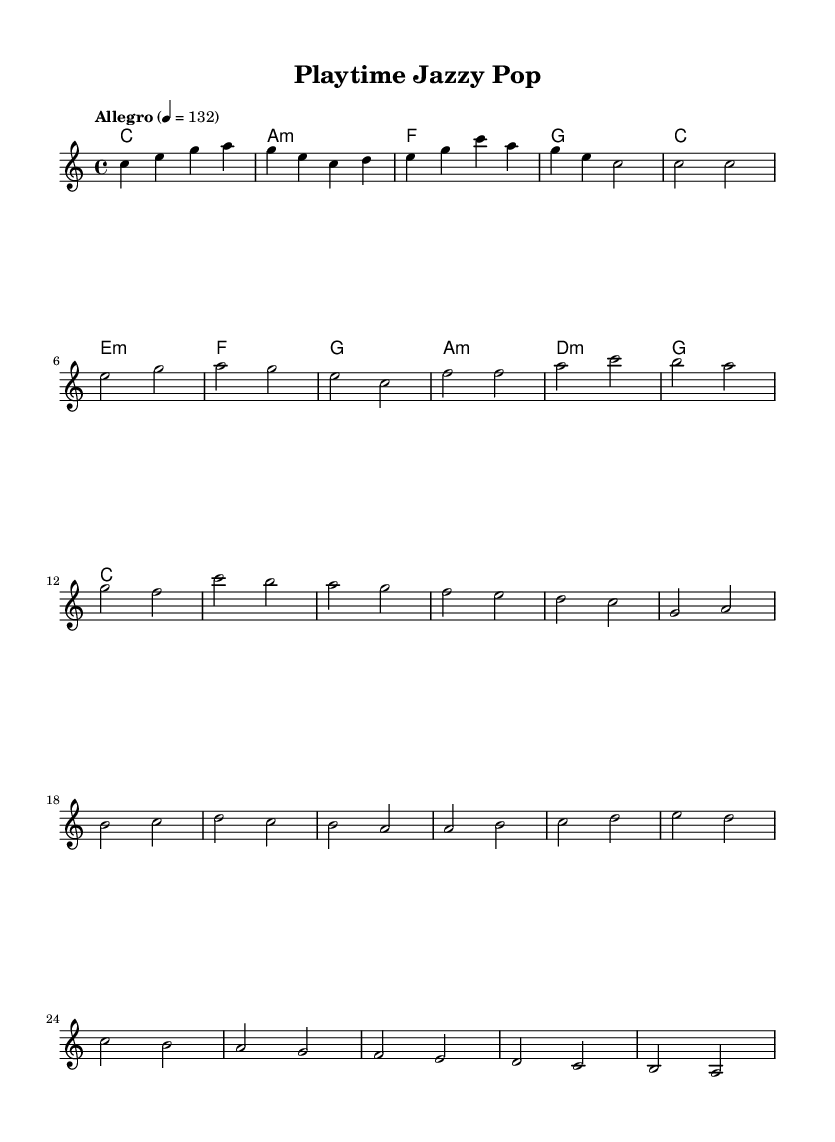What is the key signature of this music? The key signature is indicated at the beginning of the staff, showing no sharps or flats, which signifies that the piece is in C major.
Answer: C major What is the time signature of this music? The time signature is indicated at the beginning of the music as 4/4, meaning there are four beats in each measure.
Answer: 4/4 What is the tempo marking for this piece? The tempo marking at the beginning states "Allegro" with a metronome indication of 132 beats per minute, suggesting a fast, lively pace.
Answer: Allegro, 132 How many measures are in the verse section? The verse section is comprised of four measures, as noted by measuring the bar lines present in that section of the music.
Answer: 4 What are the first four notes of the melody? The first four notes of the melody are indicated in the intro section and are C, E, G, A, represented in a rising order in the notes.
Answer: C, E, G, A Which chords are used in the chorus? The chords in the chorus consist of F, E minor, D minor, and C, as indicated in the chord progression shown above the melody.
Answer: F, E minor, D minor, C What is the characteristic sound of the fusion style represented in this sheet? The fusion style combines upbeat jazz rhythms with pop melodies and playful, toy-like sound effects, which can typically be inferred from the lightheartedness of the composition structure.
Answer: Upbeat jazz-pop fusion 